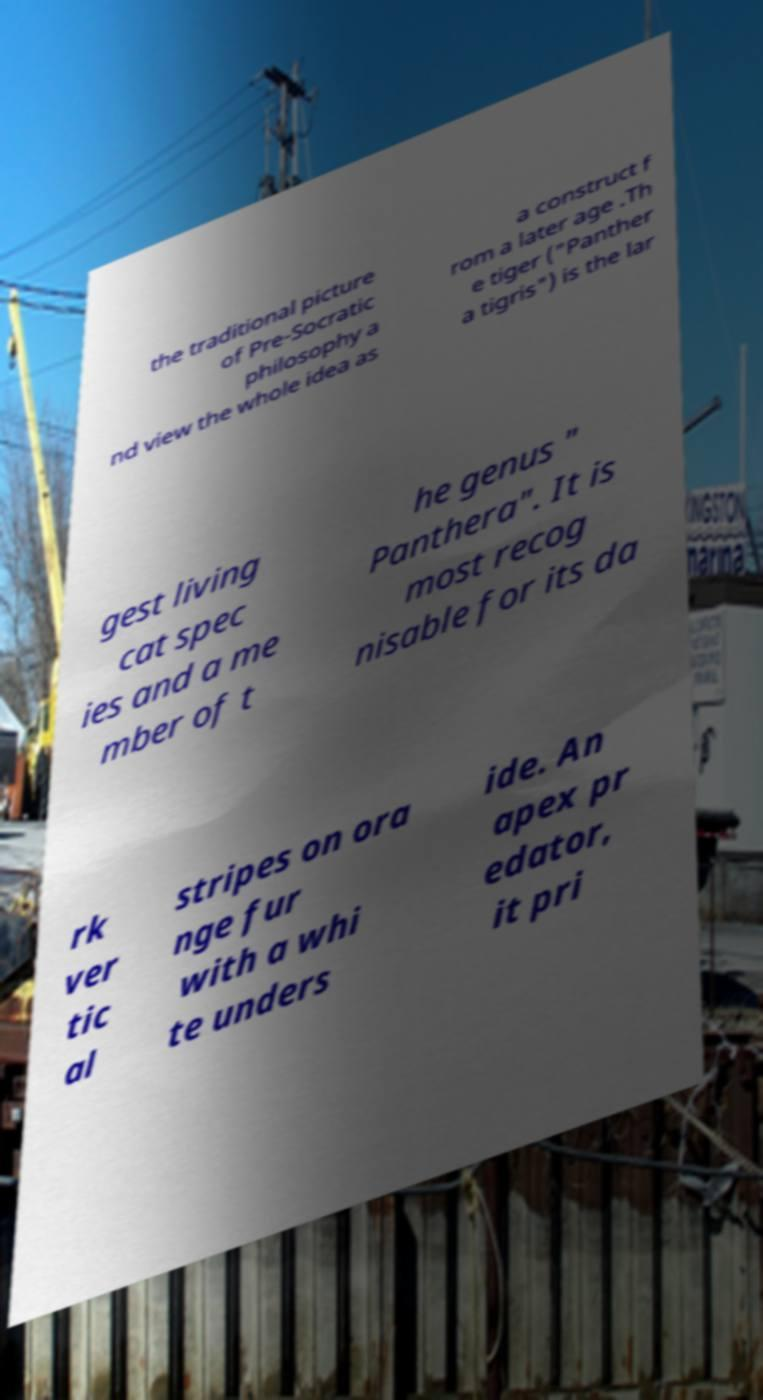Can you accurately transcribe the text from the provided image for me? the traditional picture of Pre-Socratic philosophy a nd view the whole idea as a construct f rom a later age .Th e tiger ("Panther a tigris") is the lar gest living cat spec ies and a me mber of t he genus " Panthera". It is most recog nisable for its da rk ver tic al stripes on ora nge fur with a whi te unders ide. An apex pr edator, it pri 